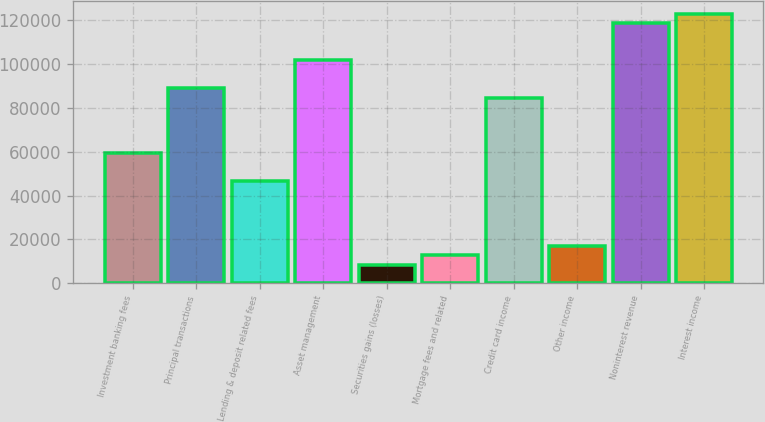Convert chart to OTSL. <chart><loc_0><loc_0><loc_500><loc_500><bar_chart><fcel>Investment banking fees<fcel>Principal transactions<fcel>Lending & deposit related fees<fcel>Asset management<fcel>Securities gains (losses)<fcel>Mortgage fees and related<fcel>Credit card income<fcel>Other income<fcel>Noninterest revenue<fcel>Interest income<nl><fcel>59320.2<fcel>88979.6<fcel>46609<fcel>101691<fcel>8475.48<fcel>12712.5<fcel>84742.6<fcel>16949.6<fcel>118639<fcel>122876<nl></chart> 